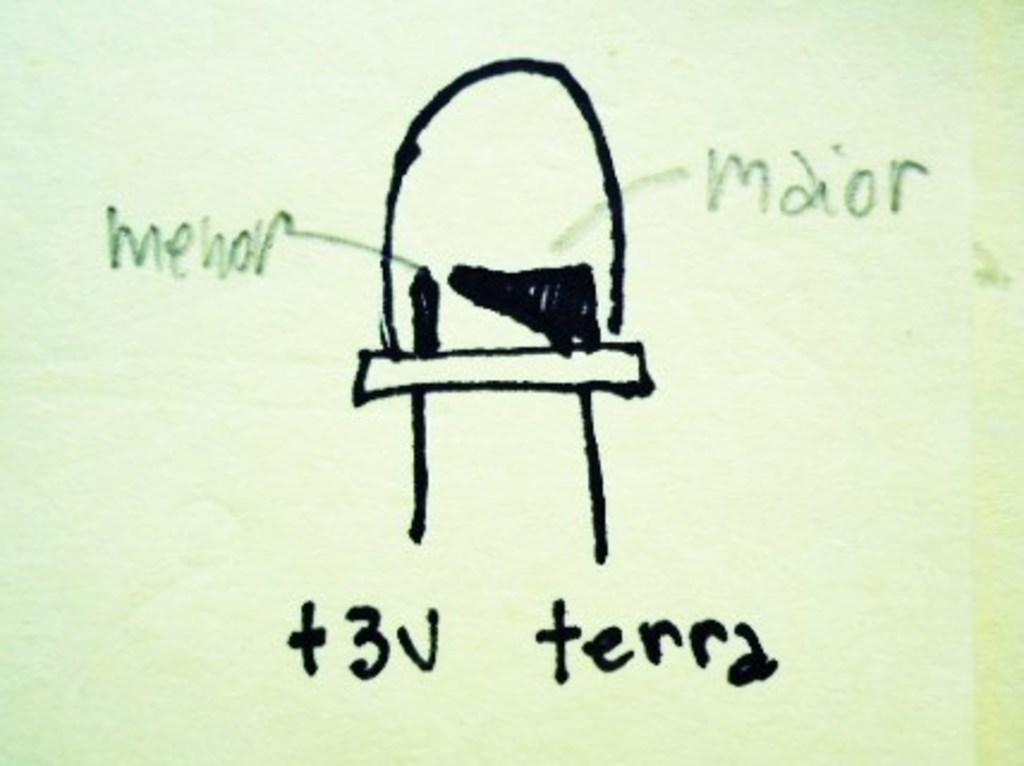What is present on the paper in the image? There is a paper in the image, with a diagram and text on it. Can you describe the diagram on the paper? Unfortunately, the specific details of the diagram cannot be determined from the provided facts. What type of information is conveyed by the text on the paper? The content of the text on the paper cannot be determined from the provided facts. What type of haircut is the person in the image getting? There is no person in the image, nor is there any indication of a haircut. 